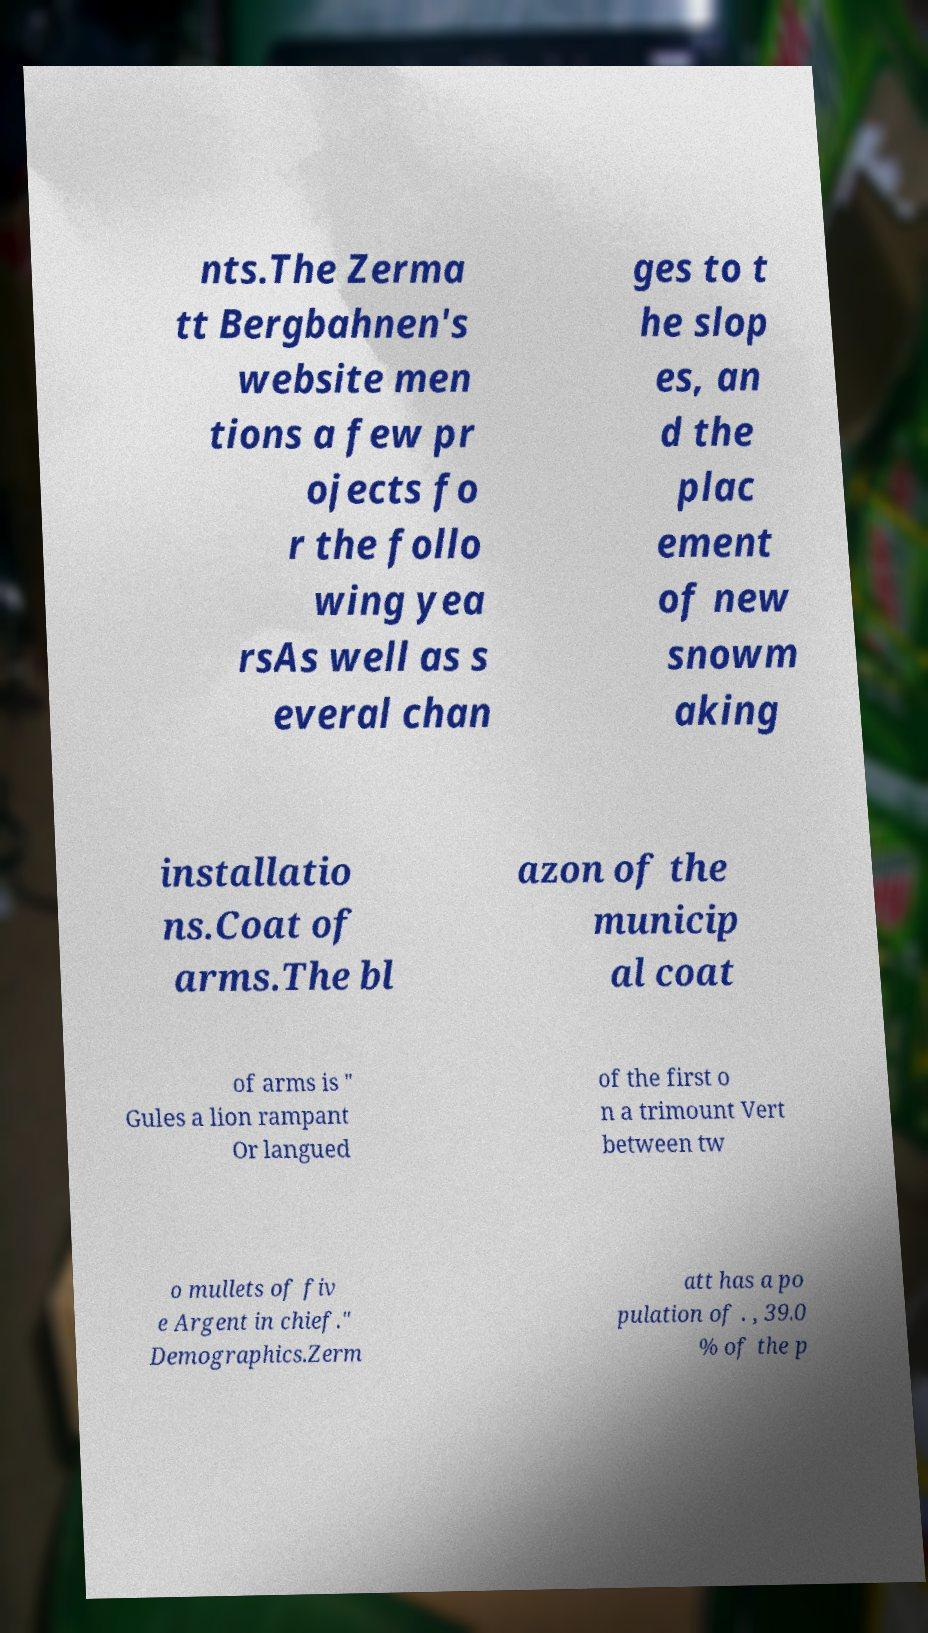There's text embedded in this image that I need extracted. Can you transcribe it verbatim? nts.The Zerma tt Bergbahnen's website men tions a few pr ojects fo r the follo wing yea rsAs well as s everal chan ges to t he slop es, an d the plac ement of new snowm aking installatio ns.Coat of arms.The bl azon of the municip al coat of arms is " Gules a lion rampant Or langued of the first o n a trimount Vert between tw o mullets of fiv e Argent in chief." Demographics.Zerm att has a po pulation of . , 39.0 % of the p 